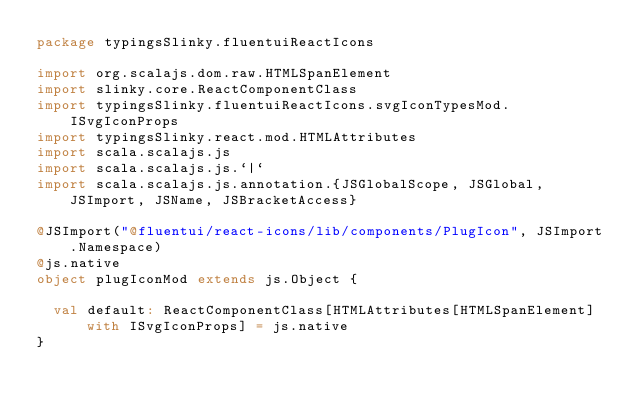<code> <loc_0><loc_0><loc_500><loc_500><_Scala_>package typingsSlinky.fluentuiReactIcons

import org.scalajs.dom.raw.HTMLSpanElement
import slinky.core.ReactComponentClass
import typingsSlinky.fluentuiReactIcons.svgIconTypesMod.ISvgIconProps
import typingsSlinky.react.mod.HTMLAttributes
import scala.scalajs.js
import scala.scalajs.js.`|`
import scala.scalajs.js.annotation.{JSGlobalScope, JSGlobal, JSImport, JSName, JSBracketAccess}

@JSImport("@fluentui/react-icons/lib/components/PlugIcon", JSImport.Namespace)
@js.native
object plugIconMod extends js.Object {
  
  val default: ReactComponentClass[HTMLAttributes[HTMLSpanElement] with ISvgIconProps] = js.native
}
</code> 